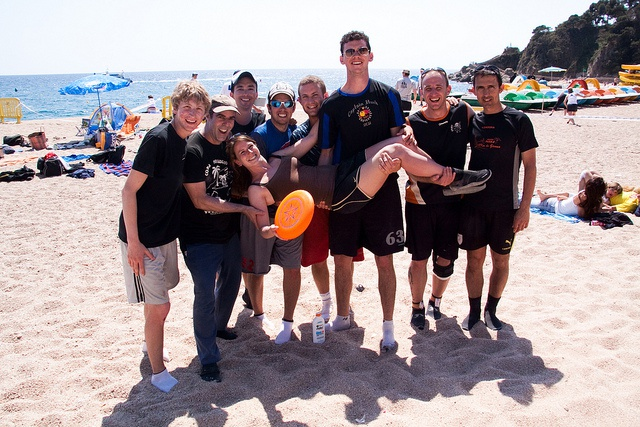Describe the objects in this image and their specific colors. I can see people in white, black, brown, gray, and darkgray tones, people in white, black, maroon, brown, and gray tones, people in white, black, maroon, brown, and gray tones, people in white, black, brown, and maroon tones, and people in white, black, brown, and maroon tones in this image. 